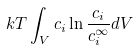<formula> <loc_0><loc_0><loc_500><loc_500>k T \int _ { V } c _ { i } \ln \frac { c _ { i } } { c _ { i } ^ { \infty } } d V</formula> 